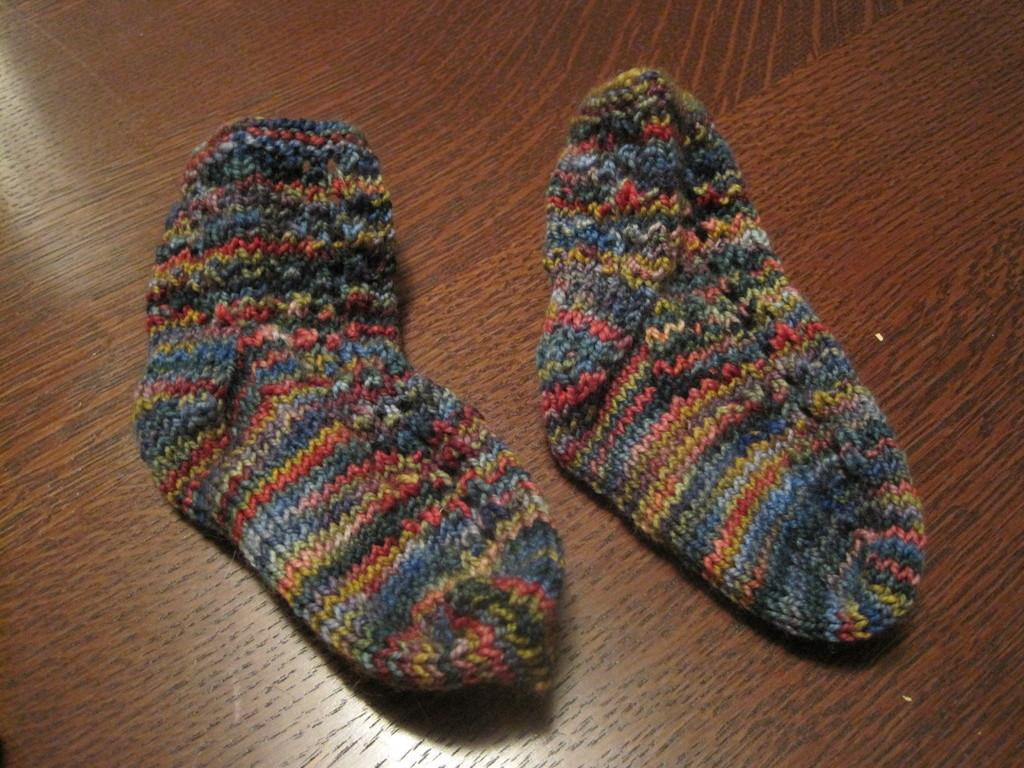What items are on the table in the image? There are socks on the table in the image. How many dolls are sitting on the bag in the image? There are no dolls or bags present in the image; it only features socks on the table. 